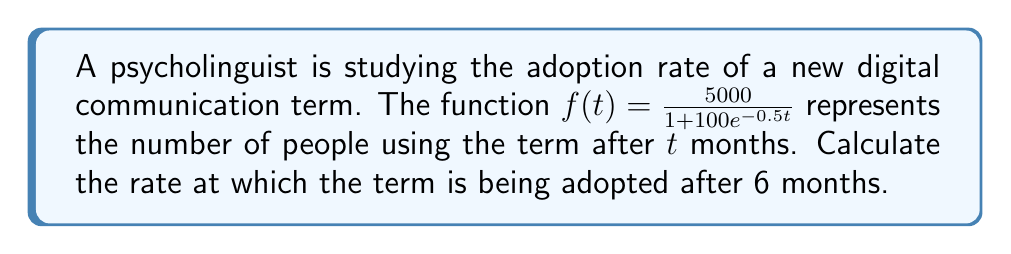Solve this math problem. To find the rate of adoption at 6 months, we need to calculate the derivative of $f(t)$ and evaluate it at $t=6$. Here's the step-by-step process:

1) First, let's find the derivative of $f(t)$ using the quotient rule:

   $f'(t) = \frac{d}{dt}\left(\frac{5000}{1 + 100e^{-0.5t}}\right)$

2) Apply the quotient rule: $\frac{d}{dx}\left(\frac{u}{v}\right) = \frac{v\frac{du}{dx} - u\frac{dv}{dx}}{v^2}$

   $f'(t) = \frac{(1 + 100e^{-0.5t})(0) - 5000(-50e^{-0.5t})}{(1 + 100e^{-0.5t})^2}$

3) Simplify:

   $f'(t) = \frac{250000e^{-0.5t}}{(1 + 100e^{-0.5t})^2}$

4) Now, evaluate $f'(t)$ at $t=6$:

   $f'(6) = \frac{250000e^{-0.5(6)}}{(1 + 100e^{-0.5(6)})^2}$

5) Calculate $e^{-3} \approx 0.0498$:

   $f'(6) = \frac{250000(0.0498)}{(1 + 100(0.0498))^2} \approx 611.57$

Therefore, after 6 months, the term is being adopted at a rate of approximately 611.57 people per month.
Answer: $611.57$ people/month 